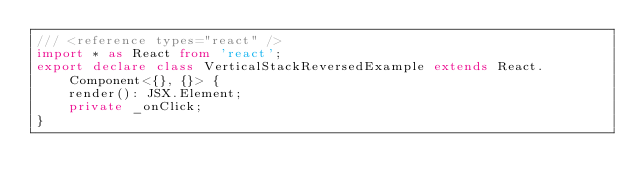Convert code to text. <code><loc_0><loc_0><loc_500><loc_500><_TypeScript_>/// <reference types="react" />
import * as React from 'react';
export declare class VerticalStackReversedExample extends React.Component<{}, {}> {
    render(): JSX.Element;
    private _onClick;
}
</code> 